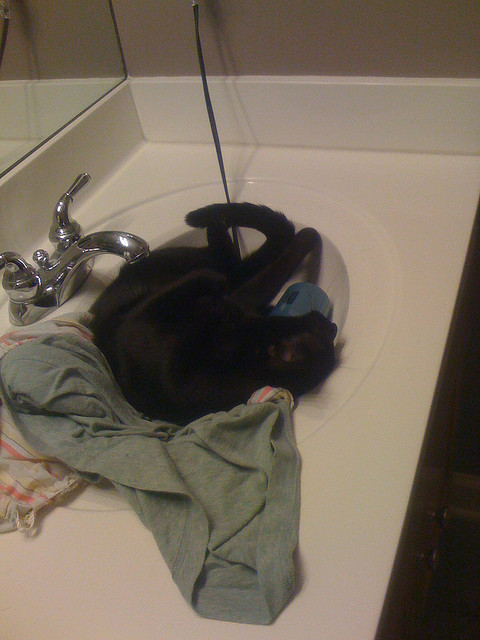What is the cat laying on in the sink? The cat is laying on a pile of clothes and towels in the sink. 